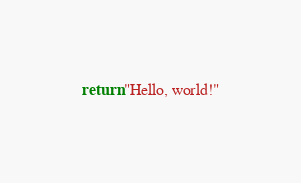Convert code to text. <code><loc_0><loc_0><loc_500><loc_500><_Lua_>return "Hello, world!"
</code> 